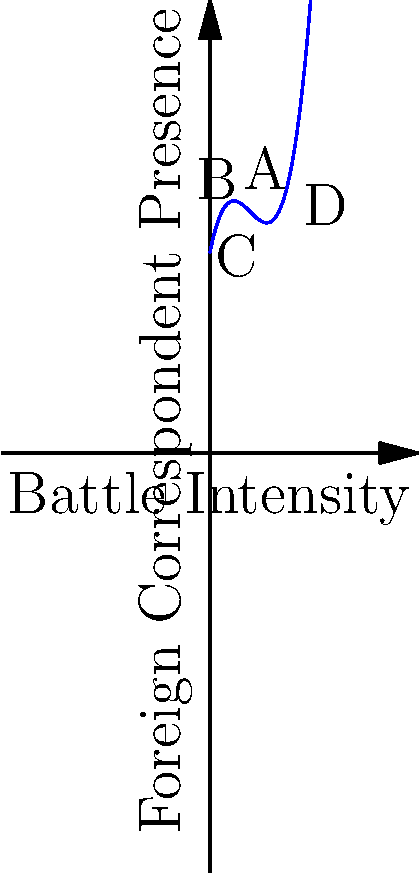The graph above represents the relationship between battle intensity (x-axis) and foreign correspondent presence (y-axis) during the Spanish Civil War. Which point on the curve indicates the highest rate of change in foreign correspondent presence with respect to battle intensity? To determine the point with the highest rate of change, we need to analyze the slope of the curve at each labeled point. The rate of change is represented by the derivative of the function.

Given that the curve is a cubic function, its general form is:

$f(x) = ax^3 + bx^2 + cx + d$

The derivative of this function is:

$f'(x) = 3ax^2 + 2bx + c$

The rate of change is highest where the absolute value of the derivative is greatest.

Let's examine the slope at each point:

1. Point A: The slope is positive and moderate.
2. Point B: The slope is close to zero, indicating a local maximum or minimum.
3. Point C: The slope is negative and steep.
4. Point D: The slope is positive and very steep.

Comparing these slopes, we can see that Point D has the steepest slope, indicating the highest rate of change.

This suggests that as battle intensity reaches higher levels, there is a rapid increase in foreign correspondent presence, possibly due to increased international interest in more intense conflicts.
Answer: Point D 